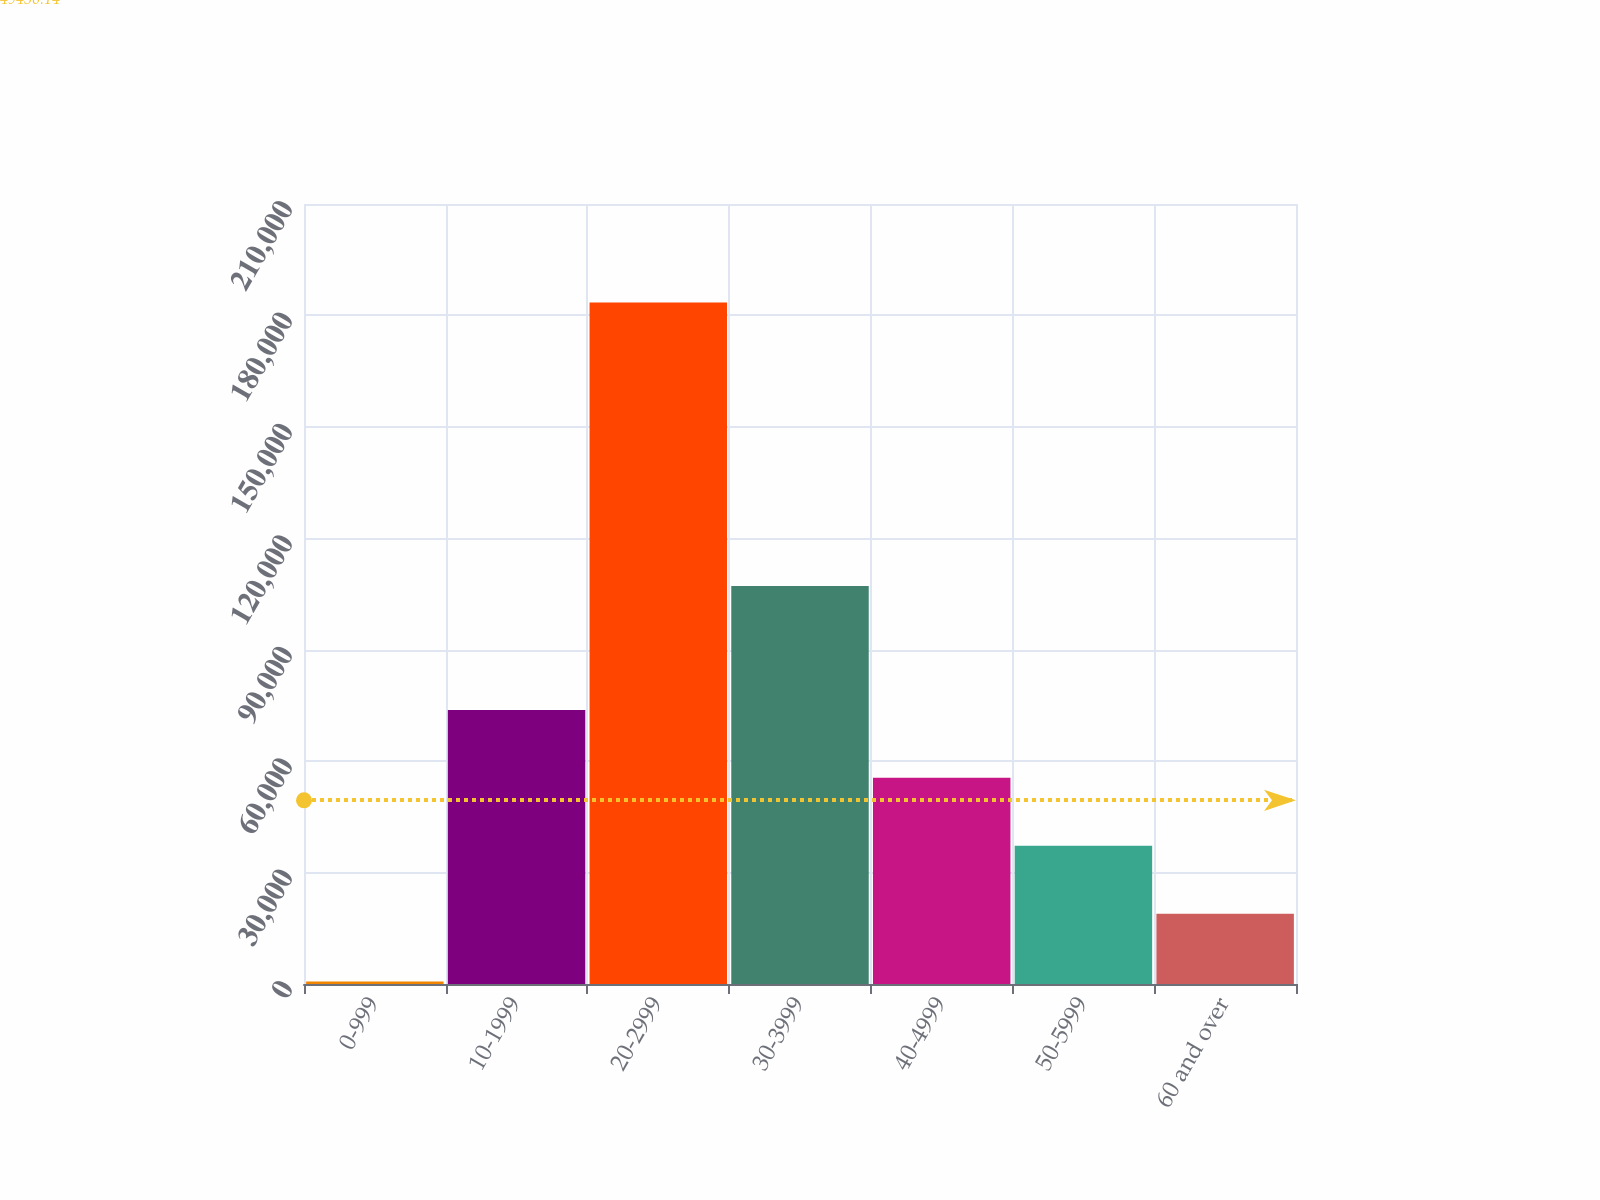Convert chart. <chart><loc_0><loc_0><loc_500><loc_500><bar_chart><fcel>0-999<fcel>10-1999<fcel>20-2999<fcel>30-3999<fcel>40-4999<fcel>50-5999<fcel>60 and over<nl><fcel>651<fcel>73778.2<fcel>183469<fcel>107171<fcel>55496.4<fcel>37214.6<fcel>18932.8<nl></chart> 